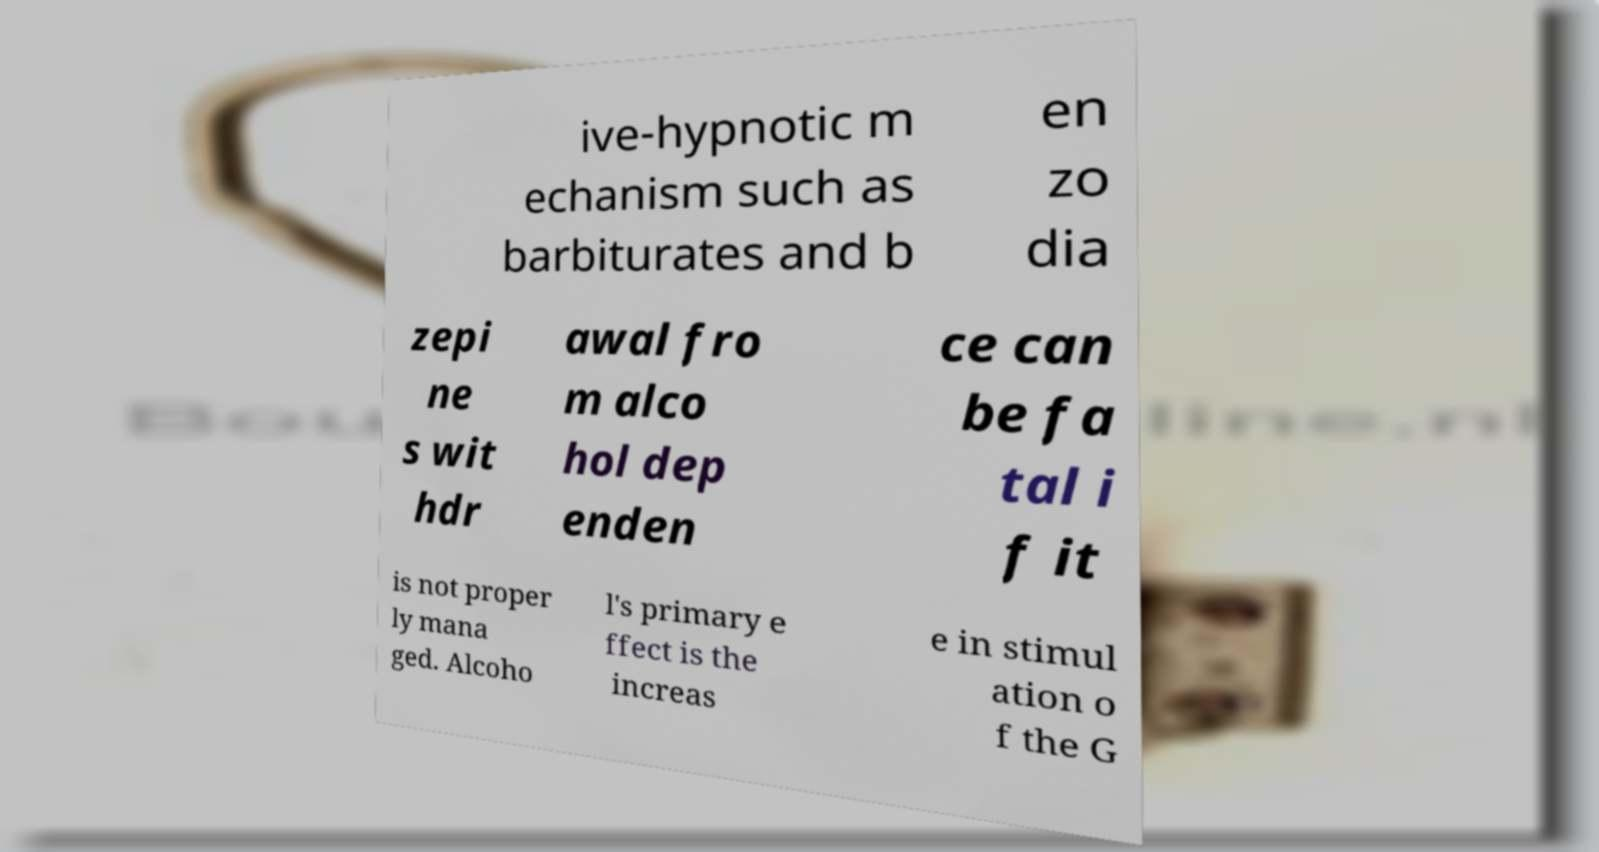What messages or text are displayed in this image? I need them in a readable, typed format. ive-hypnotic m echanism such as barbiturates and b en zo dia zepi ne s wit hdr awal fro m alco hol dep enden ce can be fa tal i f it is not proper ly mana ged. Alcoho l's primary e ffect is the increas e in stimul ation o f the G 